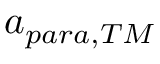<formula> <loc_0><loc_0><loc_500><loc_500>a _ { p a r a , T M }</formula> 